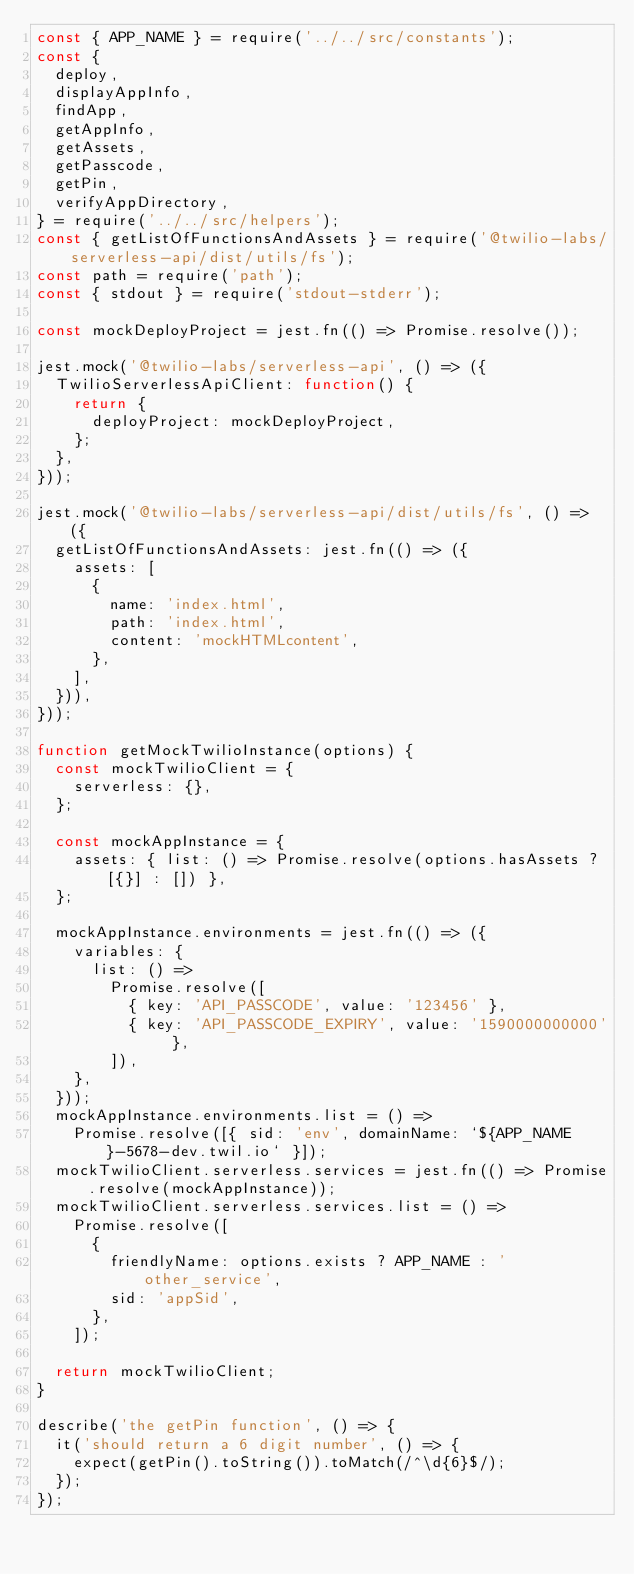<code> <loc_0><loc_0><loc_500><loc_500><_JavaScript_>const { APP_NAME } = require('../../src/constants');
const {
  deploy,
  displayAppInfo,
  findApp,
  getAppInfo,
  getAssets,
  getPasscode,
  getPin,
  verifyAppDirectory,
} = require('../../src/helpers');
const { getListOfFunctionsAndAssets } = require('@twilio-labs/serverless-api/dist/utils/fs');
const path = require('path');
const { stdout } = require('stdout-stderr');

const mockDeployProject = jest.fn(() => Promise.resolve());

jest.mock('@twilio-labs/serverless-api', () => ({
  TwilioServerlessApiClient: function() {
    return {
      deployProject: mockDeployProject,
    };
  },
}));

jest.mock('@twilio-labs/serverless-api/dist/utils/fs', () => ({
  getListOfFunctionsAndAssets: jest.fn(() => ({
    assets: [
      {
        name: 'index.html',
        path: 'index.html',
        content: 'mockHTMLcontent',
      },
    ],
  })),
}));

function getMockTwilioInstance(options) {
  const mockTwilioClient = {
    serverless: {},
  };

  const mockAppInstance = {
    assets: { list: () => Promise.resolve(options.hasAssets ? [{}] : []) },
  };

  mockAppInstance.environments = jest.fn(() => ({
    variables: {
      list: () =>
        Promise.resolve([
          { key: 'API_PASSCODE', value: '123456' },
          { key: 'API_PASSCODE_EXPIRY', value: '1590000000000' },
        ]),
    },
  }));
  mockAppInstance.environments.list = () =>
    Promise.resolve([{ sid: 'env', domainName: `${APP_NAME}-5678-dev.twil.io` }]);
  mockTwilioClient.serverless.services = jest.fn(() => Promise.resolve(mockAppInstance));
  mockTwilioClient.serverless.services.list = () =>
    Promise.resolve([
      {
        friendlyName: options.exists ? APP_NAME : 'other_service',
        sid: 'appSid',
      },
    ]);

  return mockTwilioClient;
}

describe('the getPin function', () => {
  it('should return a 6 digit number', () => {
    expect(getPin().toString()).toMatch(/^\d{6}$/);
  });
});
</code> 